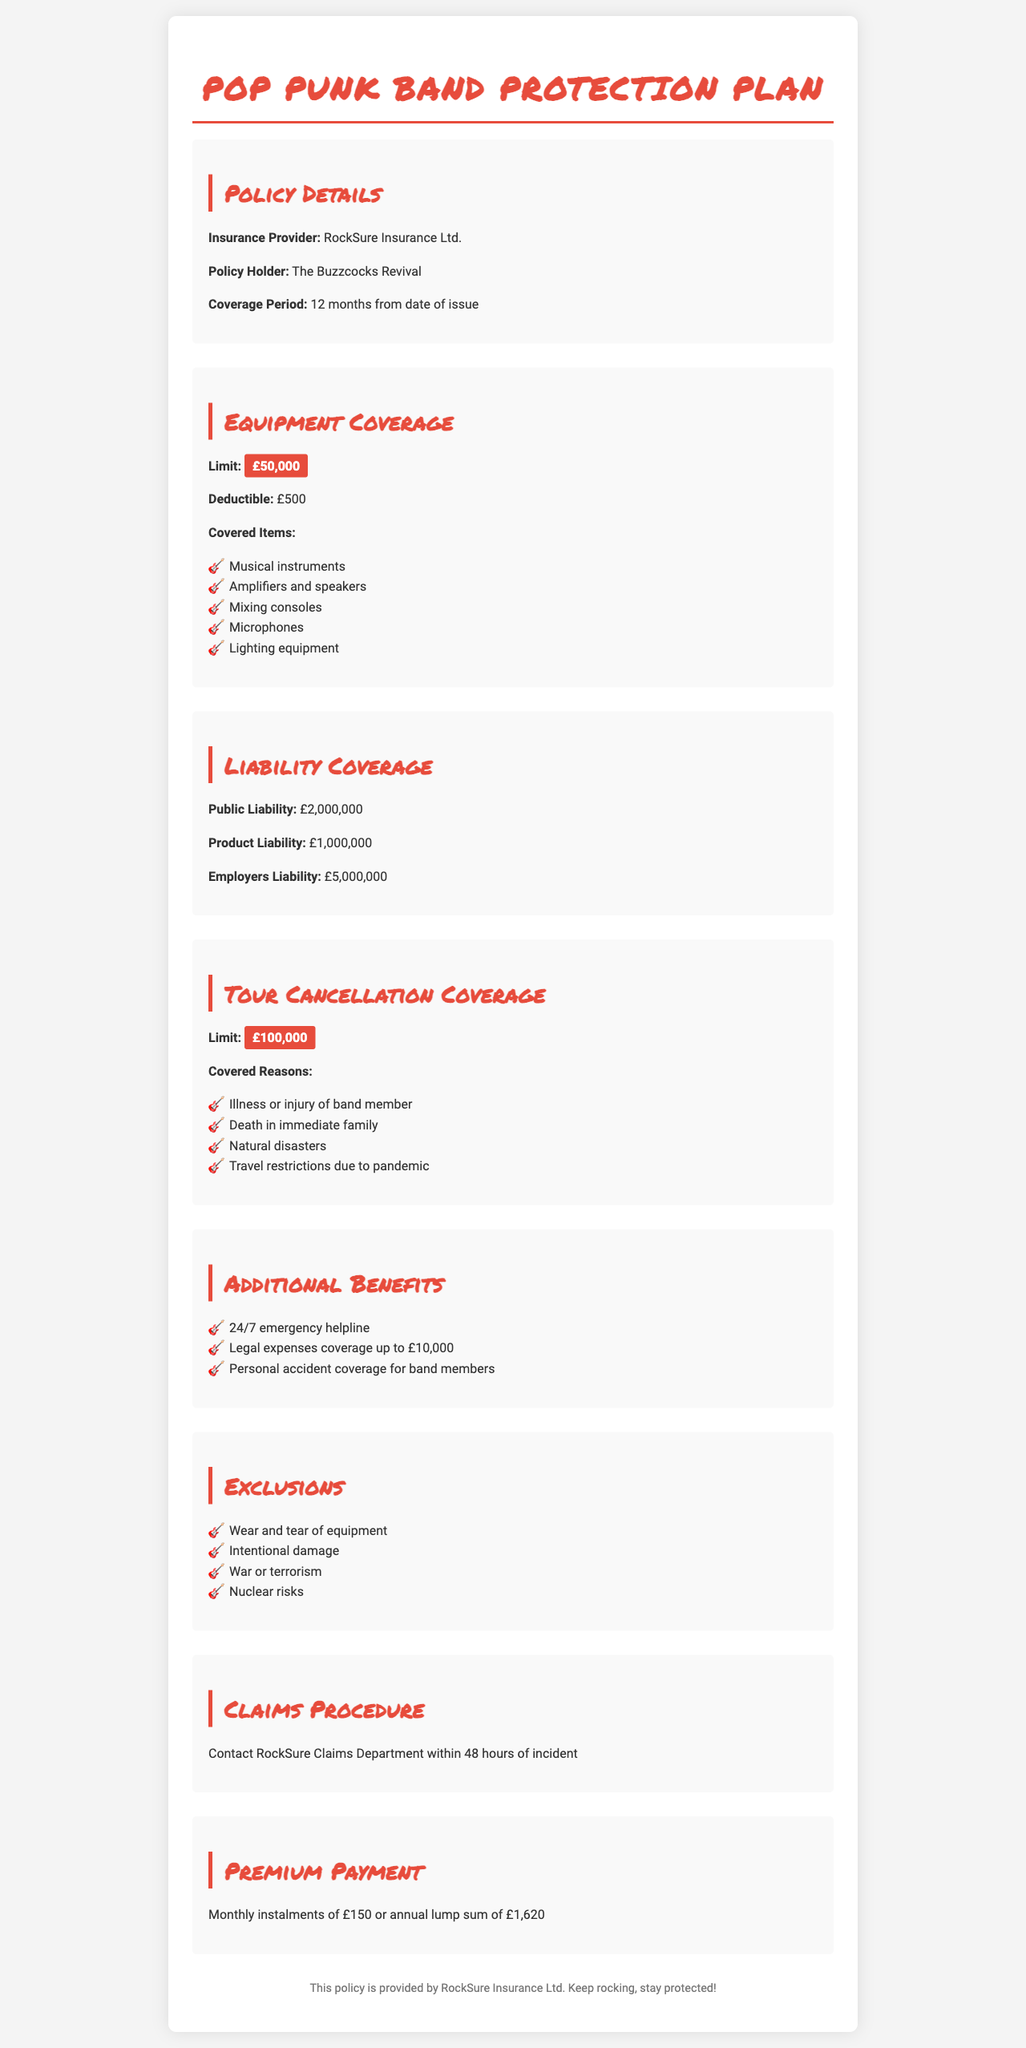What is the insurance provider? The insurance provider is specified in the "Policy Details" section, where it mentions RockSure Insurance Ltd.
Answer: RockSure Insurance Ltd What is the equipment coverage limit? The limit for equipment coverage is stated in the "Equipment Coverage" section, which highlights that the coverage limit is £50,000.
Answer: £50,000 What is the deductible amount for equipment? The deductible amount is mentioned in the "Equipment Coverage" section. It is described as £500.
Answer: £500 What is the public liability coverage amount? The public liability coverage is detailed in the "Liability Coverage" section, where it states £2,000,000.
Answer: £2,000,000 What are the covered reasons for tour cancellation? The "Tour Cancellation Coverage" section lists various reasons, including illness or injury of a band member, which are reasons for coverage.
Answer: Illness or injury of band member What is the premium payment option for monthly instalments? The "Premium Payment" section outlines the payment options available and specifies monthly instalments of £150.
Answer: £150 What is the legal expenses coverage amount? The amount for legal expenses is stated in the "Additional Benefits" section, which mentions coverage up to £10,000.
Answer: £10,000 What are the exclusions mentioned in the policy? The "Exclusions" section lists situations that are not covered, such as wear and tear of equipment.
Answer: Wear and tear of equipment What should be done to initiate a claim? The "Claims Procedure" section indicates action required to initiate a claim, specifically contacting the RockSure Claims Department.
Answer: Contact RockSure Claims Department 